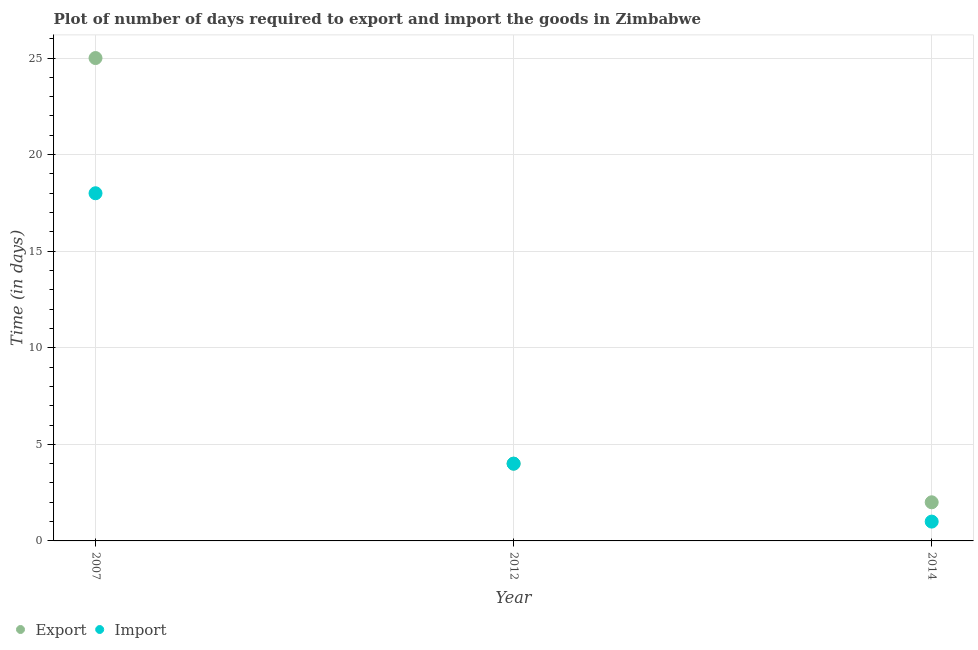What is the time required to import in 2012?
Make the answer very short. 4. Across all years, what is the maximum time required to import?
Your answer should be compact. 18. Across all years, what is the minimum time required to export?
Give a very brief answer. 2. What is the total time required to import in the graph?
Your answer should be very brief. 23. What is the difference between the time required to import in 2007 and that in 2014?
Offer a terse response. 17. What is the difference between the time required to export in 2014 and the time required to import in 2012?
Your answer should be compact. -2. What is the average time required to import per year?
Your answer should be very brief. 7.67. In the year 2014, what is the difference between the time required to import and time required to export?
Keep it short and to the point. -1. What is the ratio of the time required to export in 2007 to that in 2012?
Provide a short and direct response. 6.25. Is the time required to export in 2007 less than that in 2012?
Offer a terse response. No. What is the difference between the highest and the second highest time required to import?
Your answer should be compact. 14. What is the difference between the highest and the lowest time required to export?
Your answer should be very brief. 23. Is the time required to import strictly greater than the time required to export over the years?
Your answer should be compact. No. Are the values on the major ticks of Y-axis written in scientific E-notation?
Give a very brief answer. No. Does the graph contain any zero values?
Give a very brief answer. No. Does the graph contain grids?
Provide a succinct answer. Yes. How many legend labels are there?
Your answer should be very brief. 2. How are the legend labels stacked?
Make the answer very short. Horizontal. What is the title of the graph?
Provide a succinct answer. Plot of number of days required to export and import the goods in Zimbabwe. What is the label or title of the X-axis?
Make the answer very short. Year. What is the label or title of the Y-axis?
Make the answer very short. Time (in days). What is the Time (in days) of Import in 2012?
Your answer should be compact. 4. What is the Time (in days) of Export in 2014?
Offer a very short reply. 2. Across all years, what is the maximum Time (in days) in Import?
Offer a terse response. 18. What is the total Time (in days) of Export in the graph?
Your response must be concise. 31. What is the difference between the Time (in days) of Export in 2007 and that in 2012?
Ensure brevity in your answer.  21. What is the difference between the Time (in days) in Import in 2007 and that in 2012?
Your answer should be very brief. 14. What is the difference between the Time (in days) in Export in 2007 and that in 2014?
Offer a very short reply. 23. What is the difference between the Time (in days) of Export in 2012 and that in 2014?
Keep it short and to the point. 2. What is the difference between the Time (in days) in Import in 2012 and that in 2014?
Offer a terse response. 3. What is the difference between the Time (in days) of Export in 2007 and the Time (in days) of Import in 2012?
Give a very brief answer. 21. What is the difference between the Time (in days) of Export in 2007 and the Time (in days) of Import in 2014?
Provide a succinct answer. 24. What is the difference between the Time (in days) in Export in 2012 and the Time (in days) in Import in 2014?
Ensure brevity in your answer.  3. What is the average Time (in days) of Export per year?
Your answer should be very brief. 10.33. What is the average Time (in days) in Import per year?
Provide a succinct answer. 7.67. In the year 2012, what is the difference between the Time (in days) in Export and Time (in days) in Import?
Your answer should be very brief. 0. In the year 2014, what is the difference between the Time (in days) in Export and Time (in days) in Import?
Your answer should be compact. 1. What is the ratio of the Time (in days) of Export in 2007 to that in 2012?
Provide a short and direct response. 6.25. What is the ratio of the Time (in days) of Import in 2007 to that in 2014?
Your response must be concise. 18. 